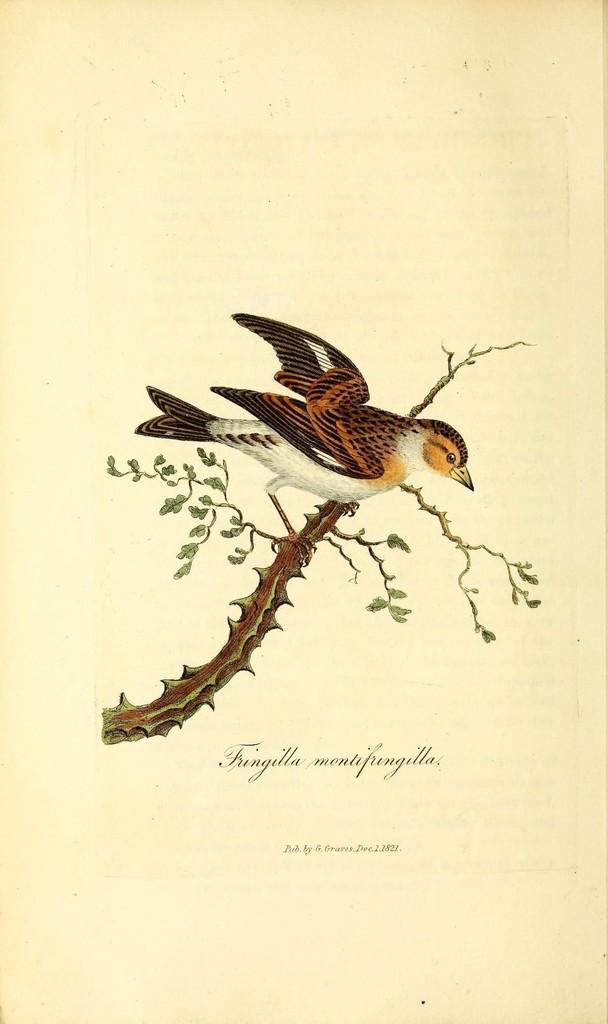How would you summarize this image in a sentence or two? In this picture there is a picture of a bird and tree on the paper and there is text on the paper. 